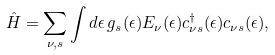<formula> <loc_0><loc_0><loc_500><loc_500>\hat { H } = \sum _ { \nu , s } \int d \epsilon \, g _ { s } ( \epsilon ) E _ { \nu } ( \epsilon ) c _ { \nu s } ^ { \dagger } ( \epsilon ) c _ { \nu s } ( \epsilon ) ,</formula> 